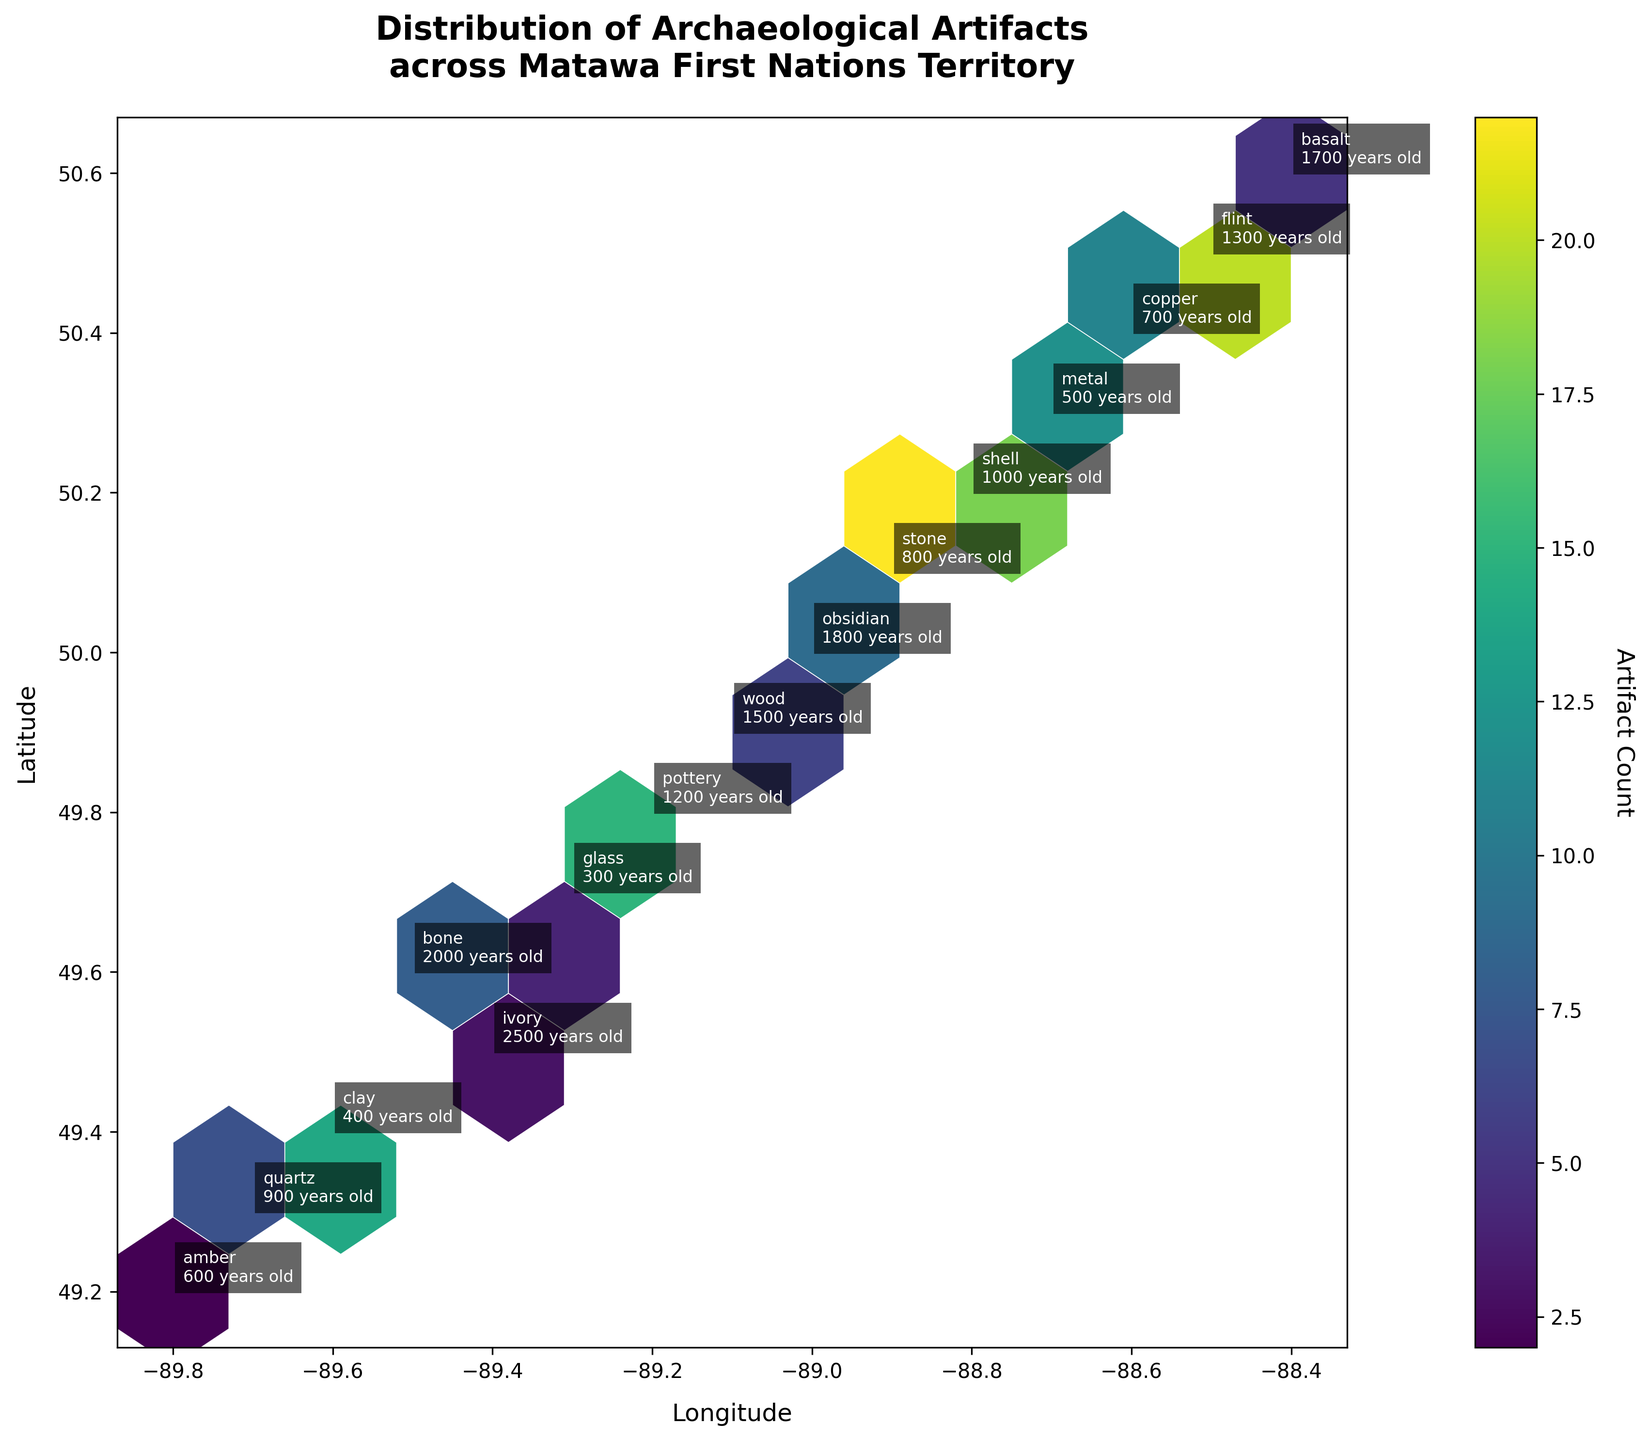What's the title of the plot? The title is usually displayed at the top of the figure. In this case, it's mentioned at the top with a descriptive text.
Answer: Distribution of Archaeological Artifacts across Matawa First Nations Territory What does the color bar represent? The color bar usually provides a scale for the color gradient used in the plot. In this plot, it indicates the artifact count.
Answer: Artifact Count How many data points are there in the southernmost part of the plot? To determine this, look at the bottom end of the latitude axis and count the annotated data points.
Answer: 5 Which material is found most frequently? Examine the hexbin plot and identify which annotated material has the highest count in its annotation.
Answer: Stone (22) Which artifact is the oldest one in the plot? Look for the annotation indicating the highest age value among the data points, which signifies the oldest artifact.
Answer: Ivory (2500 years old) What is the average age of the artifacts found at longitude -89.0? Locate data points along longitude -89.0 and calculate the average age of the annotated points using the ages provided. (1500 + 1800) / 2 = 1650
Answer: 1650 years How does the distribution of artifacts change from east to west? Observe the distribution pattern along the longitude axis, noting concentration and variations in artifact counts and material types. Higher density areas and annotations provide the required insights.
Answer: Higher artifact density in the central region; diverse materials throughout Are there more artifacts found in the northern or southern part of the plot? Compare the number of data points and the concentration of hexagons in the northern latitude range versus the southern latitude range.
Answer: Northern part What is the difference in artifact count between the highest and lowest data points? Identify the highest and lowest count values from the plot's annotations and calculate the difference. 22 (highest) - 2 (lowest) = 20
Answer: 20 Which hexagon has the highest density of artifacts and what materials are found there? Identify the hexagon with the most intense color on the hexbin plot and check the annotations for that location to find the materials.
Answer: Stone (22) at -88.9, 50.1 